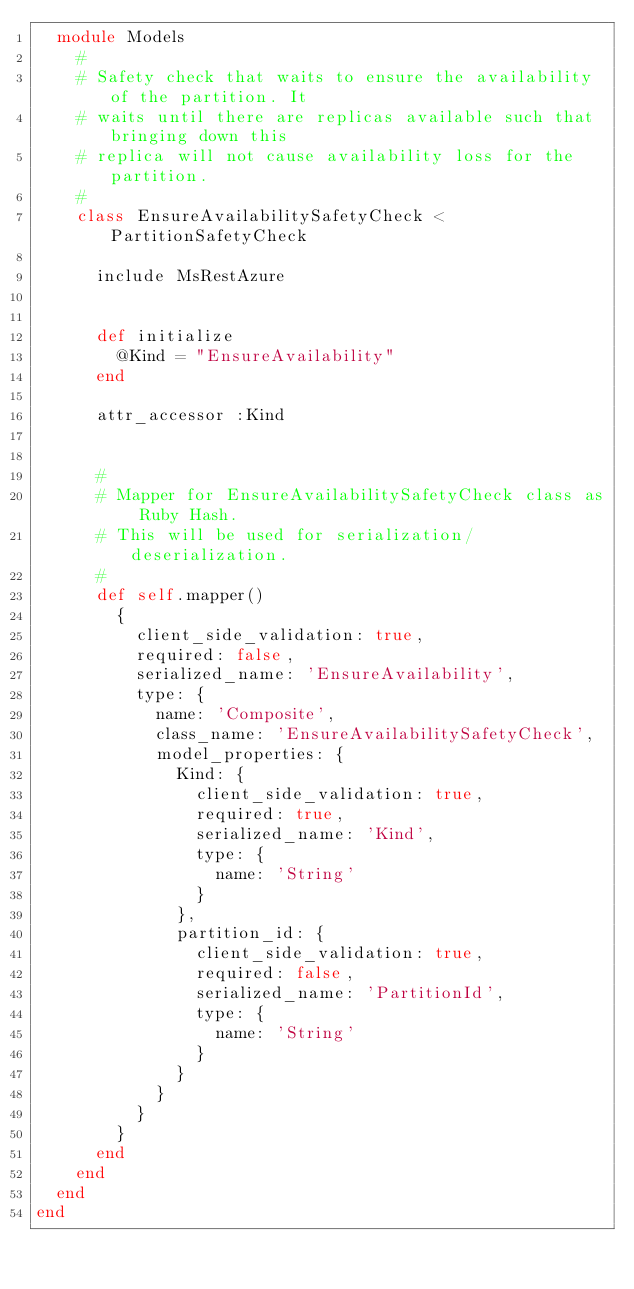Convert code to text. <code><loc_0><loc_0><loc_500><loc_500><_Ruby_>  module Models
    #
    # Safety check that waits to ensure the availability of the partition. It
    # waits until there are replicas available such that bringing down this
    # replica will not cause availability loss for the partition.
    #
    class EnsureAvailabilitySafetyCheck < PartitionSafetyCheck

      include MsRestAzure


      def initialize
        @Kind = "EnsureAvailability"
      end

      attr_accessor :Kind


      #
      # Mapper for EnsureAvailabilitySafetyCheck class as Ruby Hash.
      # This will be used for serialization/deserialization.
      #
      def self.mapper()
        {
          client_side_validation: true,
          required: false,
          serialized_name: 'EnsureAvailability',
          type: {
            name: 'Composite',
            class_name: 'EnsureAvailabilitySafetyCheck',
            model_properties: {
              Kind: {
                client_side_validation: true,
                required: true,
                serialized_name: 'Kind',
                type: {
                  name: 'String'
                }
              },
              partition_id: {
                client_side_validation: true,
                required: false,
                serialized_name: 'PartitionId',
                type: {
                  name: 'String'
                }
              }
            }
          }
        }
      end
    end
  end
end
</code> 